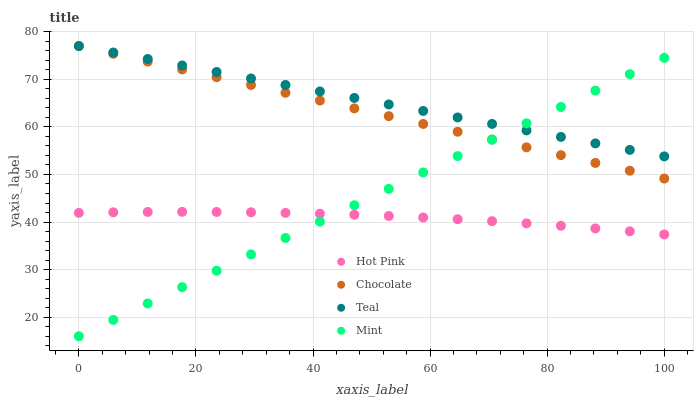Does Hot Pink have the minimum area under the curve?
Answer yes or no. Yes. Does Teal have the maximum area under the curve?
Answer yes or no. Yes. Does Mint have the minimum area under the curve?
Answer yes or no. No. Does Mint have the maximum area under the curve?
Answer yes or no. No. Is Mint the smoothest?
Answer yes or no. Yes. Is Hot Pink the roughest?
Answer yes or no. Yes. Is Teal the smoothest?
Answer yes or no. No. Is Teal the roughest?
Answer yes or no. No. Does Mint have the lowest value?
Answer yes or no. Yes. Does Teal have the lowest value?
Answer yes or no. No. Does Chocolate have the highest value?
Answer yes or no. Yes. Does Mint have the highest value?
Answer yes or no. No. Is Hot Pink less than Teal?
Answer yes or no. Yes. Is Teal greater than Hot Pink?
Answer yes or no. Yes. Does Chocolate intersect Mint?
Answer yes or no. Yes. Is Chocolate less than Mint?
Answer yes or no. No. Is Chocolate greater than Mint?
Answer yes or no. No. Does Hot Pink intersect Teal?
Answer yes or no. No. 